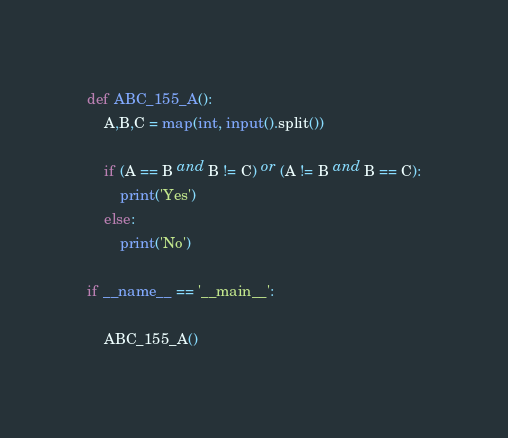<code> <loc_0><loc_0><loc_500><loc_500><_Python_>def ABC_155_A():
    A,B,C = map(int, input().split())

    if (A == B and B != C) or (A != B and B == C):
        print('Yes')
    else:
        print('No')

if __name__ == '__main__':

    ABC_155_A()</code> 